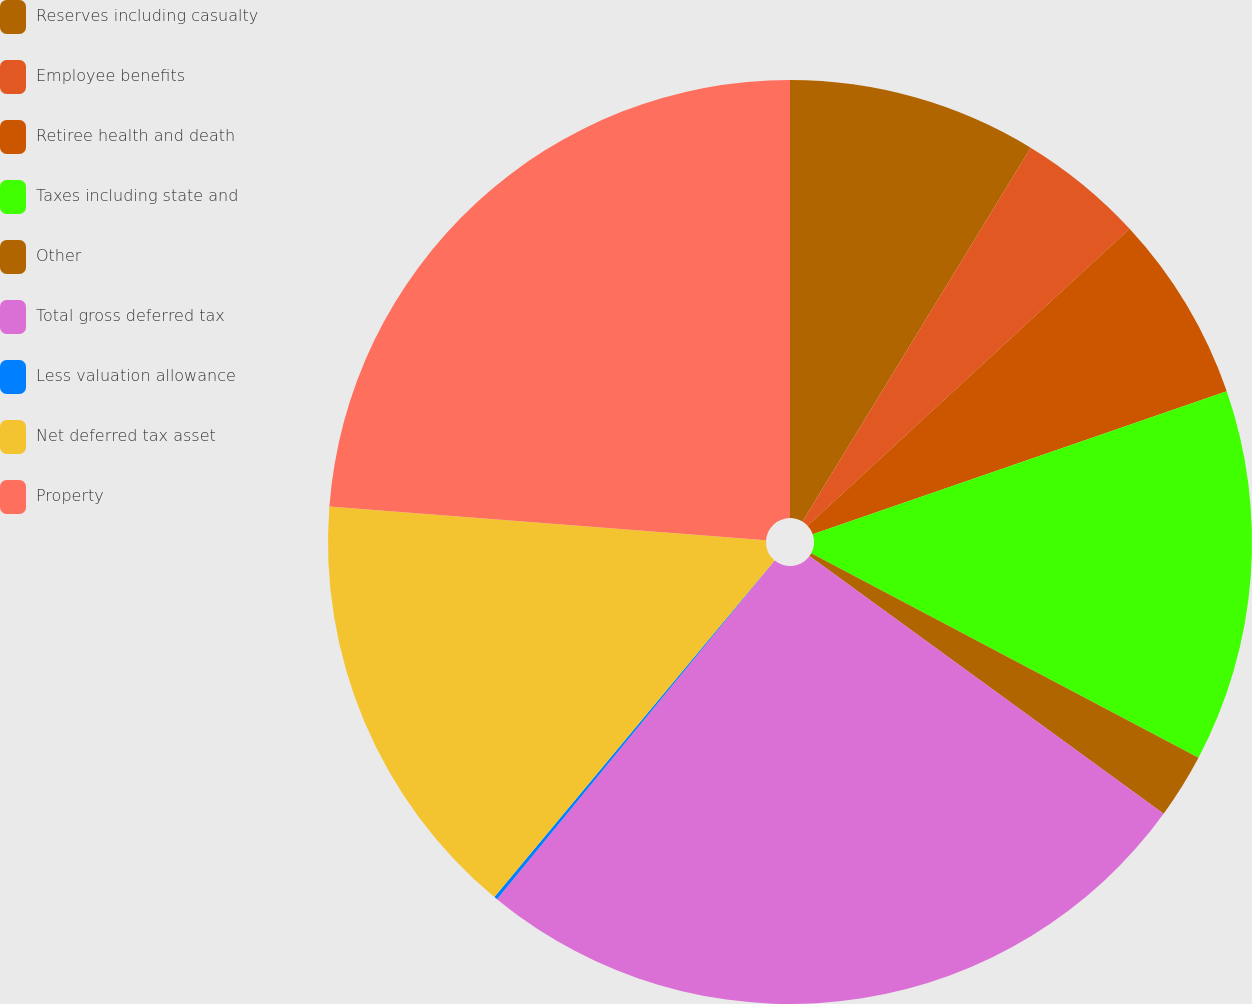<chart> <loc_0><loc_0><loc_500><loc_500><pie_chart><fcel>Reserves including casualty<fcel>Employee benefits<fcel>Retiree health and death<fcel>Taxes including state and<fcel>Other<fcel>Total gross deferred tax<fcel>Less valuation allowance<fcel>Net deferred tax asset<fcel>Property<nl><fcel>8.72%<fcel>4.42%<fcel>6.57%<fcel>13.02%<fcel>2.27%<fcel>25.92%<fcel>0.12%<fcel>15.17%<fcel>23.77%<nl></chart> 